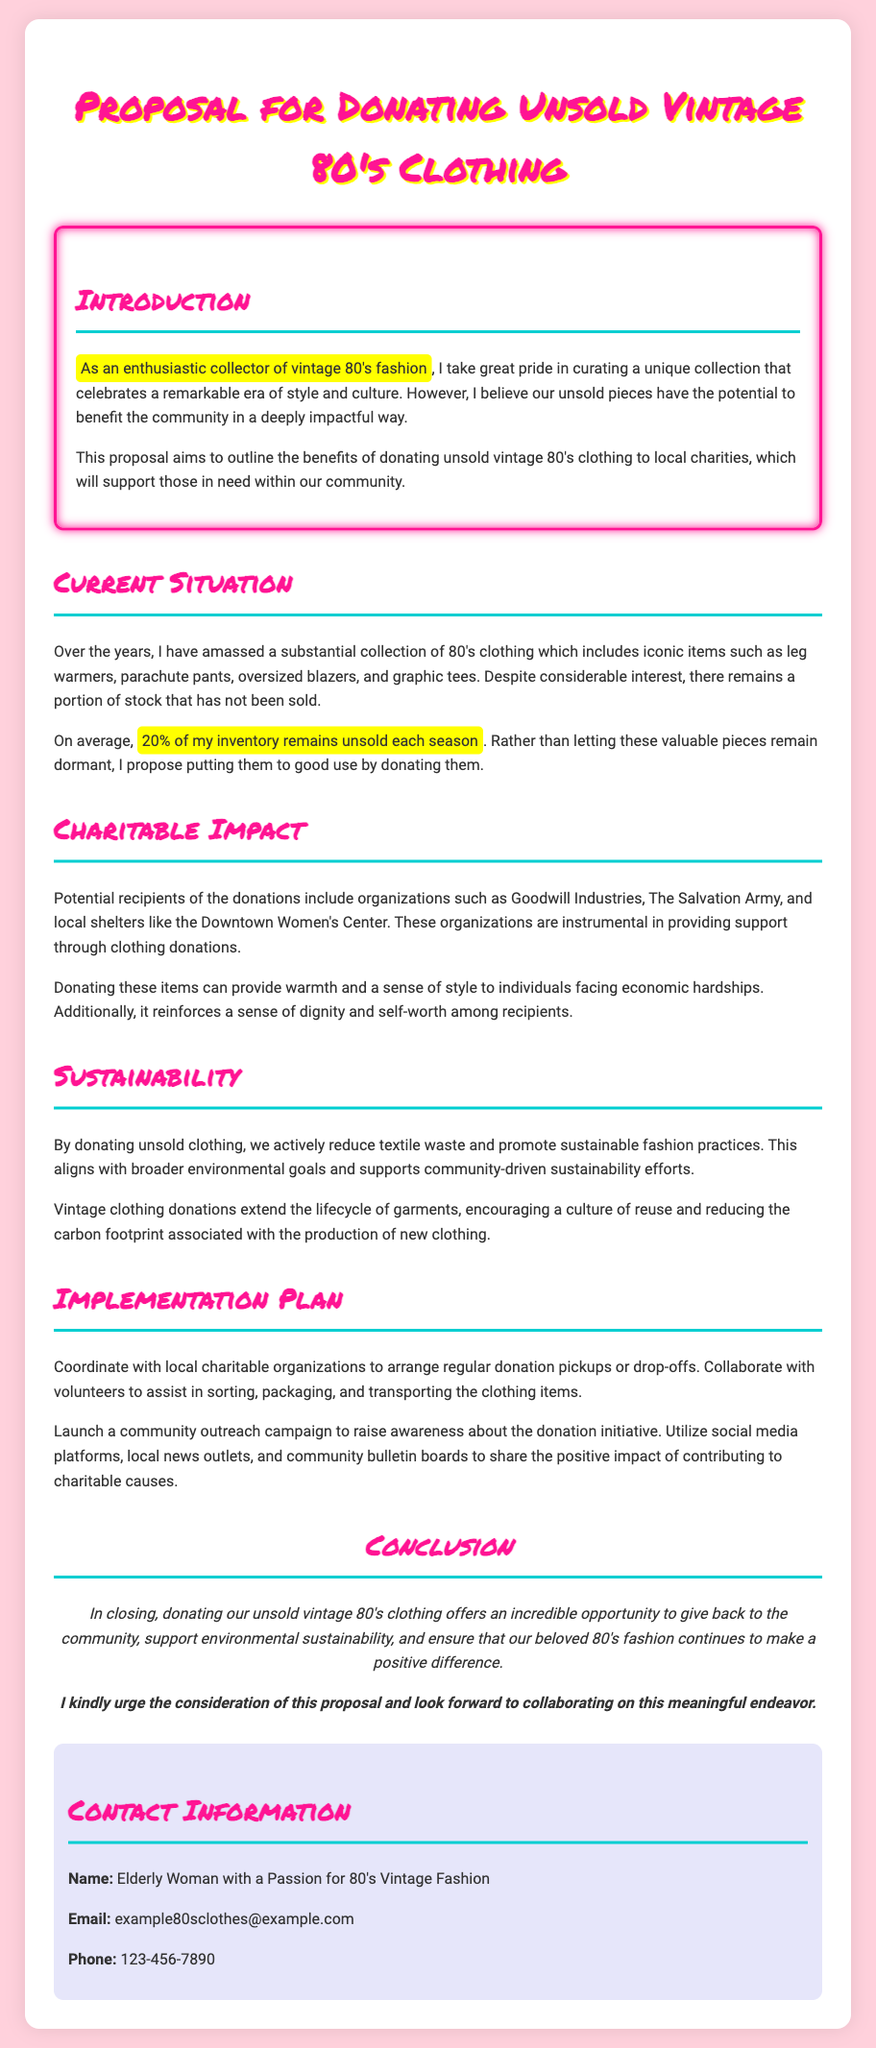What percentage of the inventory remains unsold each season? The proposal states that on average, 20% of the inventory remains unsold each season.
Answer: 20% What type of clothing items does the proposal mention? The document lists iconic items such as leg warmers, parachute pants, oversized blazers, and graphic tees as part of the collection.
Answer: leg warmers, parachute pants, oversized blazers, graphic tees Which organizations are mentioned as potential recipients of the donations? The proposal identifies Goodwill Industries, The Salvation Army, and local shelters like the Downtown Women's Center as potential recipients.
Answer: Goodwill Industries, The Salvation Army, Downtown Women's Center What main benefit does the proposal highlight about donating unsold clothing? The proposal emphasizes that donating these items can provide warmth and a sense of style to individuals facing economic hardships.
Answer: warmth and a sense of style What does the proposal suggest to promote sustainability? It states that by donating unsold clothing, we actively reduce textile waste and promote sustainable fashion practices.
Answer: reduce textile waste How does the proposal suggest to arrange donation pickups? It mentions coordinating with local charitable organizations to arrange regular donation pickups or drop-offs.
Answer: coordinating with local charitable organizations What is the overall aim of this proposal? The aim is to outline the benefits of donating unsold vintage 80's clothing to local charities, supporting those in need within the community.
Answer: benefits of donating What type of outreach does the proposal recommend? It recommends launching a community outreach campaign utilizing social media, local news outlets, and community bulletin boards.
Answer: community outreach campaign 